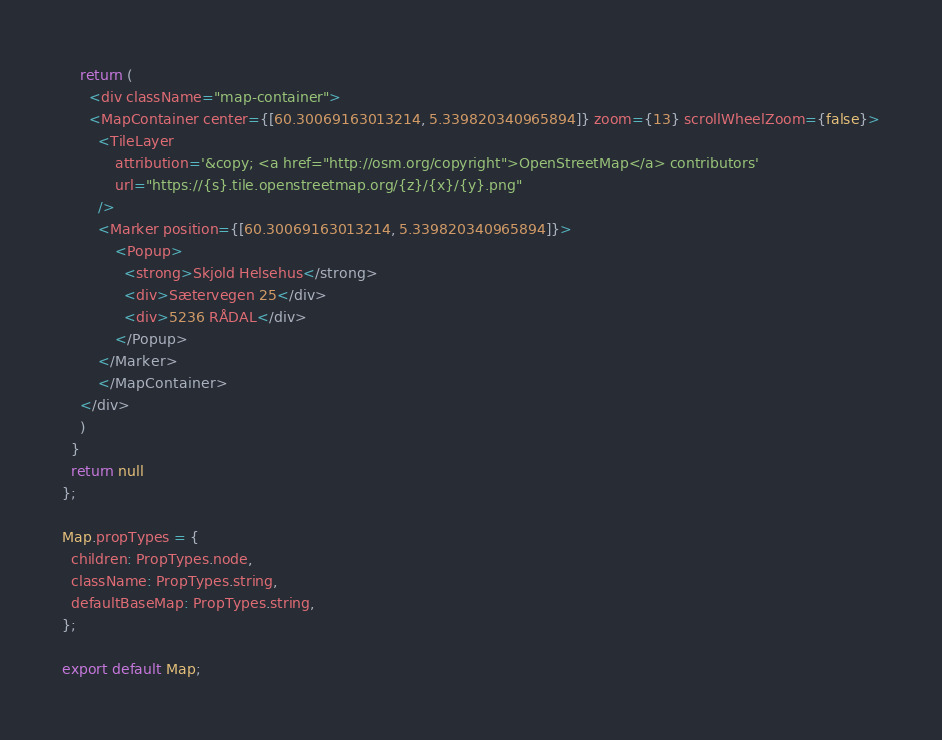<code> <loc_0><loc_0><loc_500><loc_500><_JavaScript_>    return (
      <div className="map-container">
      <MapContainer center={[60.30069163013214, 5.339820340965894]} zoom={13} scrollWheelZoom={false}>
        <TileLayer
            attribution='&copy; <a href="http://osm.org/copyright">OpenStreetMap</a> contributors'
            url="https://{s}.tile.openstreetmap.org/{z}/{x}/{y}.png"
        />
        <Marker position={[60.30069163013214, 5.339820340965894]}>
            <Popup>
              <strong>Skjold Helsehus</strong>
              <div>Sætervegen 25</div>
              <div>5236 RÅDAL</div>
            </Popup>
        </Marker>
        </MapContainer>
    </div>
    )
  }
  return null
};

Map.propTypes = {
  children: PropTypes.node,
  className: PropTypes.string,
  defaultBaseMap: PropTypes.string,
};

export default Map;</code> 